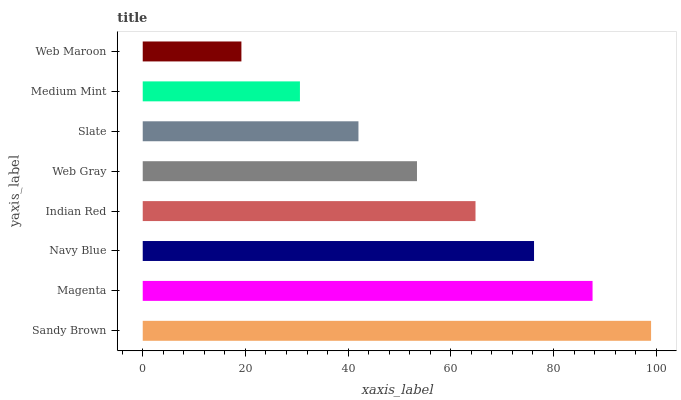Is Web Maroon the minimum?
Answer yes or no. Yes. Is Sandy Brown the maximum?
Answer yes or no. Yes. Is Magenta the minimum?
Answer yes or no. No. Is Magenta the maximum?
Answer yes or no. No. Is Sandy Brown greater than Magenta?
Answer yes or no. Yes. Is Magenta less than Sandy Brown?
Answer yes or no. Yes. Is Magenta greater than Sandy Brown?
Answer yes or no. No. Is Sandy Brown less than Magenta?
Answer yes or no. No. Is Indian Red the high median?
Answer yes or no. Yes. Is Web Gray the low median?
Answer yes or no. Yes. Is Web Maroon the high median?
Answer yes or no. No. Is Navy Blue the low median?
Answer yes or no. No. 